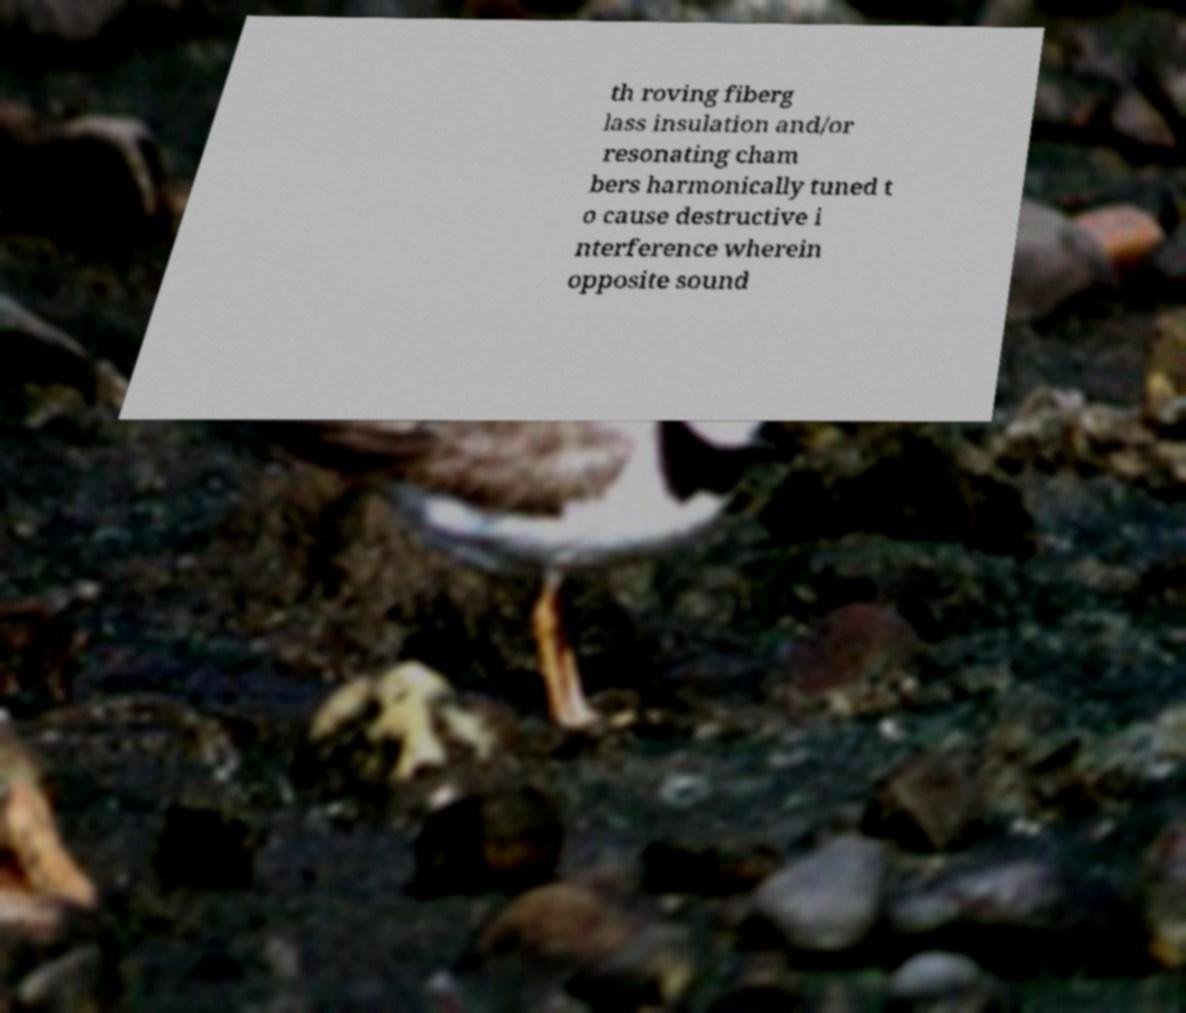Can you read and provide the text displayed in the image?This photo seems to have some interesting text. Can you extract and type it out for me? th roving fiberg lass insulation and/or resonating cham bers harmonically tuned t o cause destructive i nterference wherein opposite sound 